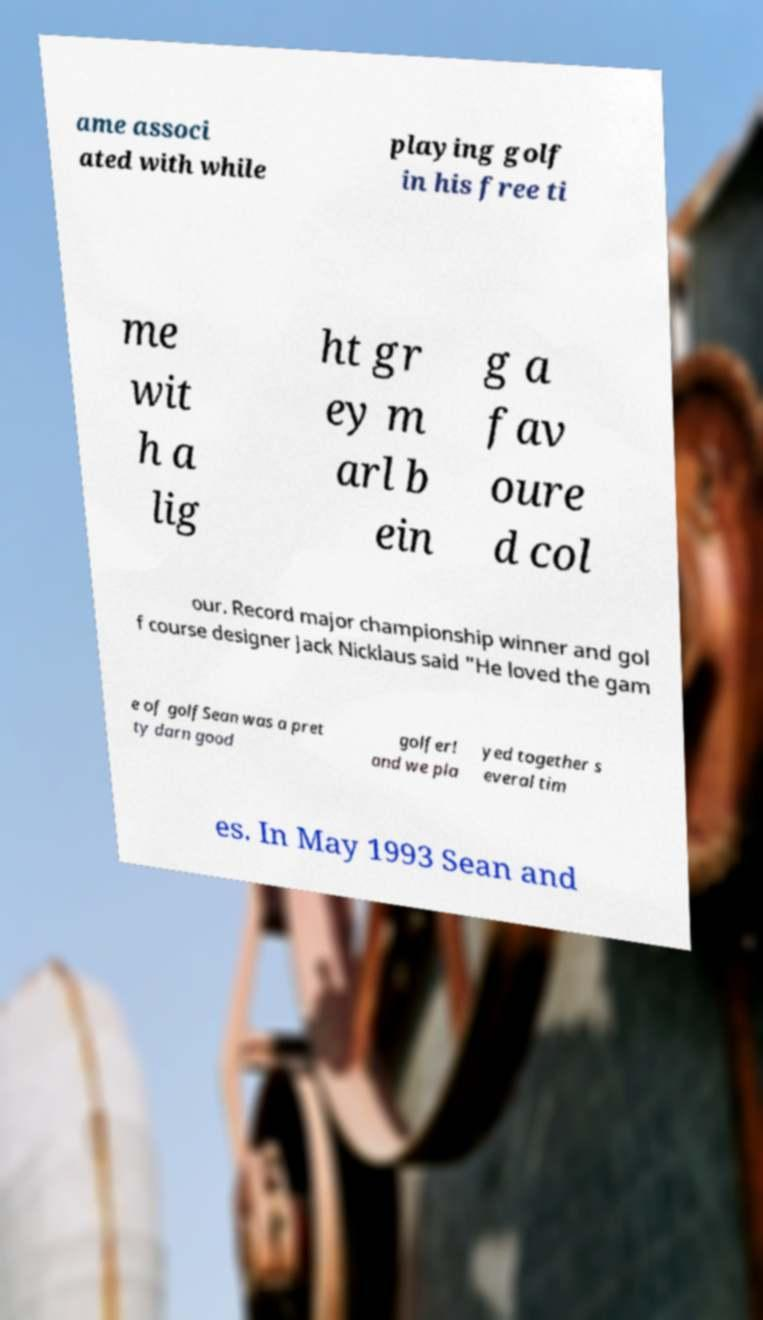Can you read and provide the text displayed in the image?This photo seems to have some interesting text. Can you extract and type it out for me? ame associ ated with while playing golf in his free ti me wit h a lig ht gr ey m arl b ein g a fav oure d col our. Record major championship winner and gol f course designer Jack Nicklaus said "He loved the gam e of golfSean was a pret ty darn good golfer! and we pla yed together s everal tim es. In May 1993 Sean and 